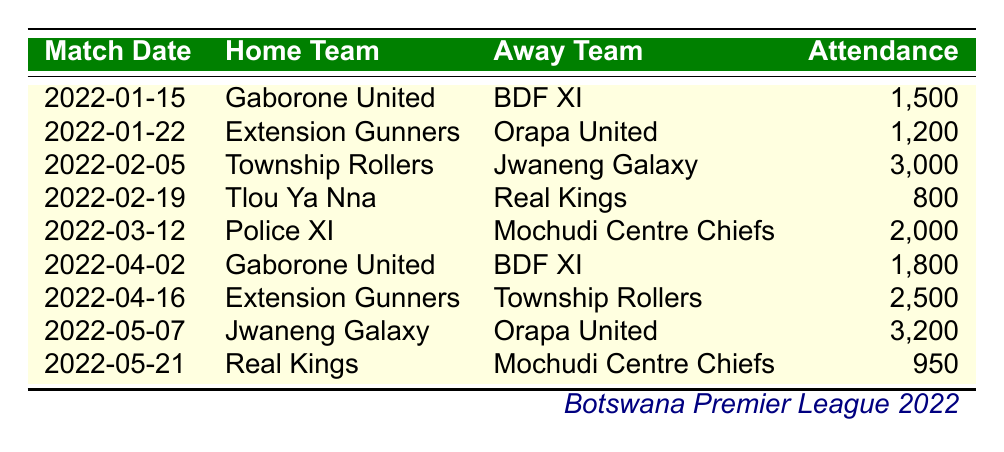What was the highest attendance recorded in the Botswana Premier League during the 2022 season? The table shows the attendance for each match. Looking through the attendance figures, the highest attendance is 3,200, which occurred during the match on May 7, 2022.
Answer: 3200 Which home team had the lowest attendance in their match? By checking the attendance figures for all home teams, the home team with the lowest attendance is Tlou Ya Nna, with only 800 attending their match against Real Kings on February 19, 2022.
Answer: Tlou Ya Nna What is the total attendance for matches involving Gaborone United? Gaborone United played two matches in the dataset with attendances of 1,500 and 1,800. Summing these gives: 1,500 + 1,800 = 3,300. Thus, the total attendance for matches involving Gaborone United is 3,300.
Answer: 3300 Were there any matches played with an attendance of more than 2,500? By reviewing the attendance figures, there are two matches that had attendances exceeding 2,500: the match on February 5, 2022, with 3,000 and the match on May 7, 2022, with 3,200. Hence, the answer is yes.
Answer: Yes What was the average attendance for the matches played by Extension Gunners? Extension Gunners had two matches with attendances of 1,200 and 2,500. To calculate the average: (1,200 + 2,500) / 2 = 3,700 / 2 = 1,850. Therefore, the average attendance for Extension Gunners is 1,850.
Answer: 1850 Which away team played in a match with the highest attendance? The away team Jwaneng Galaxy participated in the match on May 7, 2022, where the attendance reached 3,200, the highest recorded in the table. Thus, the away team with the highest attendance is Jwaneng Galaxy.
Answer: Jwaneng Galaxy Did Real Kings play in matches where the attendance was below 1,000? There are no instances in the data where Real Kings played in matches with an attendance below 1,000. Their lowest attendance recorded is 950, which is still above 1,000. Hence, the answer is no.
Answer: No How many matches were played with an attendance of 2,000 or more? By counting the attendance numbers that are 2,000 or more in the table, we find there were four such instances: 3,000, 2,000, 2,500, and 3,200. Therefore, the total is 4 matches.
Answer: 4 What was the overall attendance figure for the matches involving Real Kings? Real Kings played two matches, with attendances of 800 and 950. Summing them gives: 800 + 950 = 1,750. Hence, the overall attendance figure for matches involving Real Kings is 1,750.
Answer: 1750 